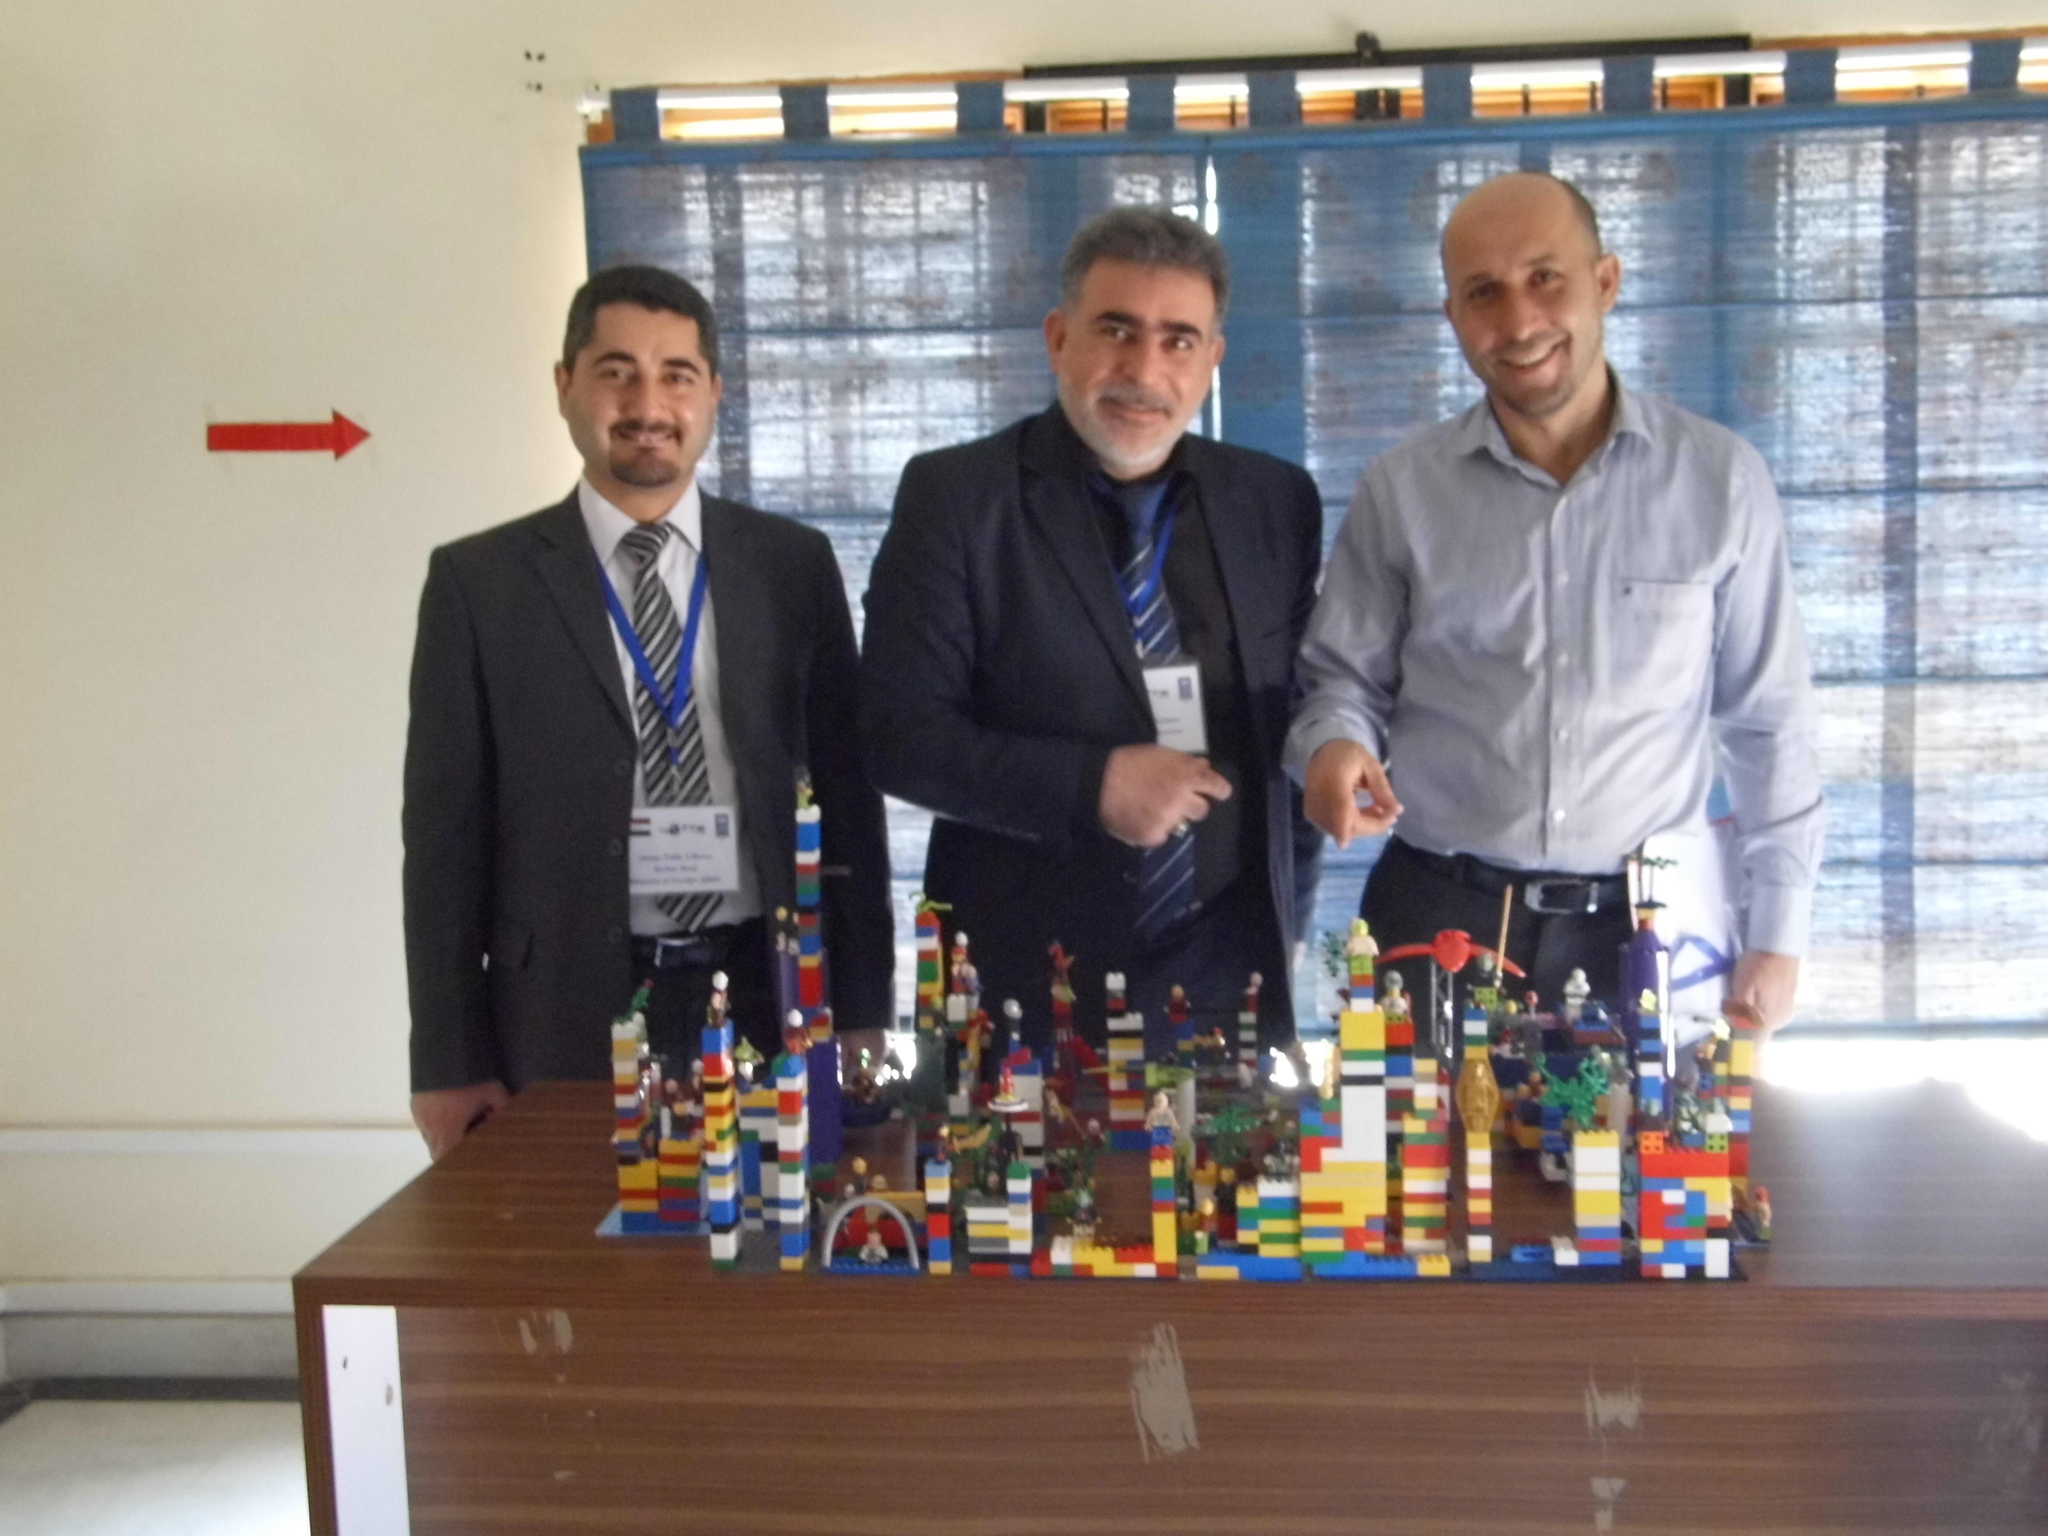What can be seen in the image involving people? There are people standing in the image. What is on the table in the image? There are objects on the table in the image. What is visible in the background of the image? There is a wall visible in the image. What type of locket is being worn by the friend in the image? There is no friend or locket present in the image. How does the popcorn contribute to the atmosphere in the image? There is no popcorn present in the image, so it cannot contribute to the atmosphere. 